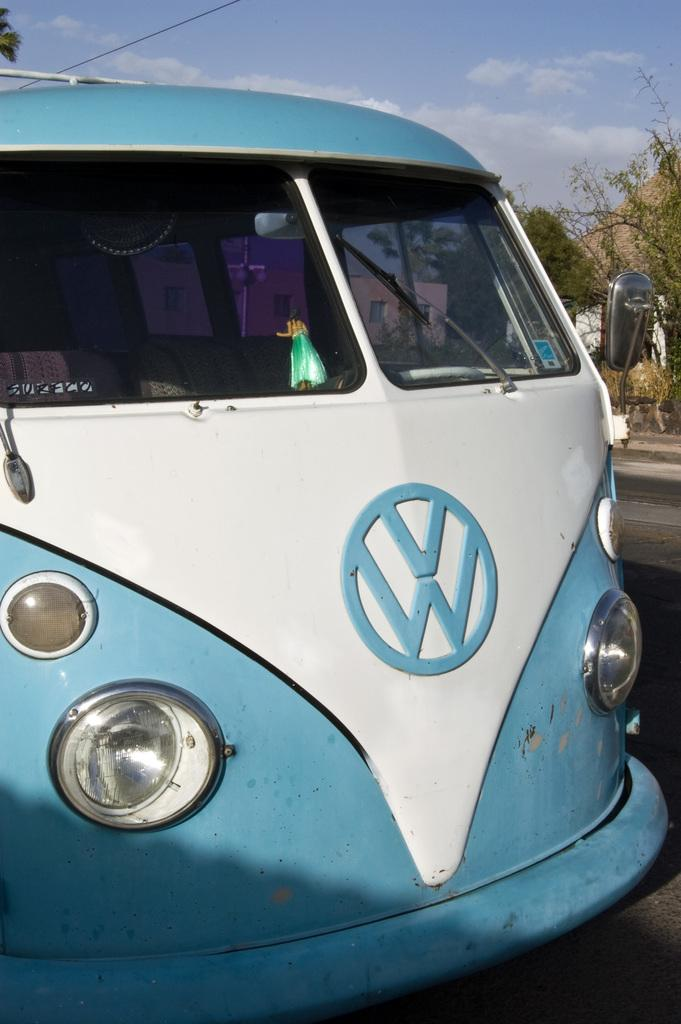<image>
Summarize the visual content of the image. A blue and white VW van has the word Sureco taped onto its windscreen. 